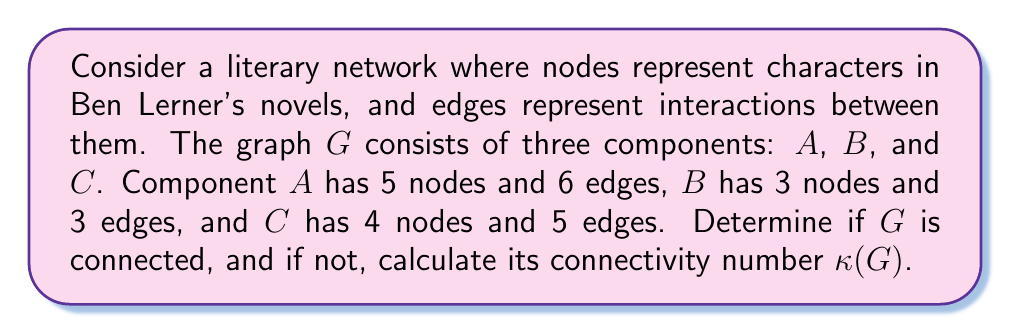Can you solve this math problem? To solve this problem, we need to understand the concepts of connectedness and connectivity number in graph theory:

1. A graph is connected if there is a path between every pair of vertices.

2. The connectivity number $\kappa(G)$ is defined as the minimum number of vertices that need to be removed to disconnect the graph. For a disconnected graph, $\kappa(G) = 0$.

Now, let's analyze the given information:

1. The graph $G$ consists of three separate components: $A$, $B$, and $C$.

2. Each component is internally connected:
   - $A$: 5 nodes, 6 edges (connected)
   - $B$: 3 nodes, 3 edges (connected)
   - $C$: 4 nodes, 5 edges (connected)

3. However, there are no edges between these components.

Since the graph has multiple disconnected components, it is not a connected graph. There is no path between vertices in different components.

To calculate the connectivity number $\kappa(G)$:
- As the graph is already disconnected, no vertices need to be removed to disconnect it.
- Therefore, $\kappa(G) = 0$.

This low connectivity number reflects the fragmented nature of the character interactions across Ben Lerner's novels, which might be an interesting point for literary analysis.
Answer: The graph $G$ is not connected, and its connectivity number is $\kappa(G) = 0$. 